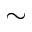<formula> <loc_0><loc_0><loc_500><loc_500>\sim</formula> 